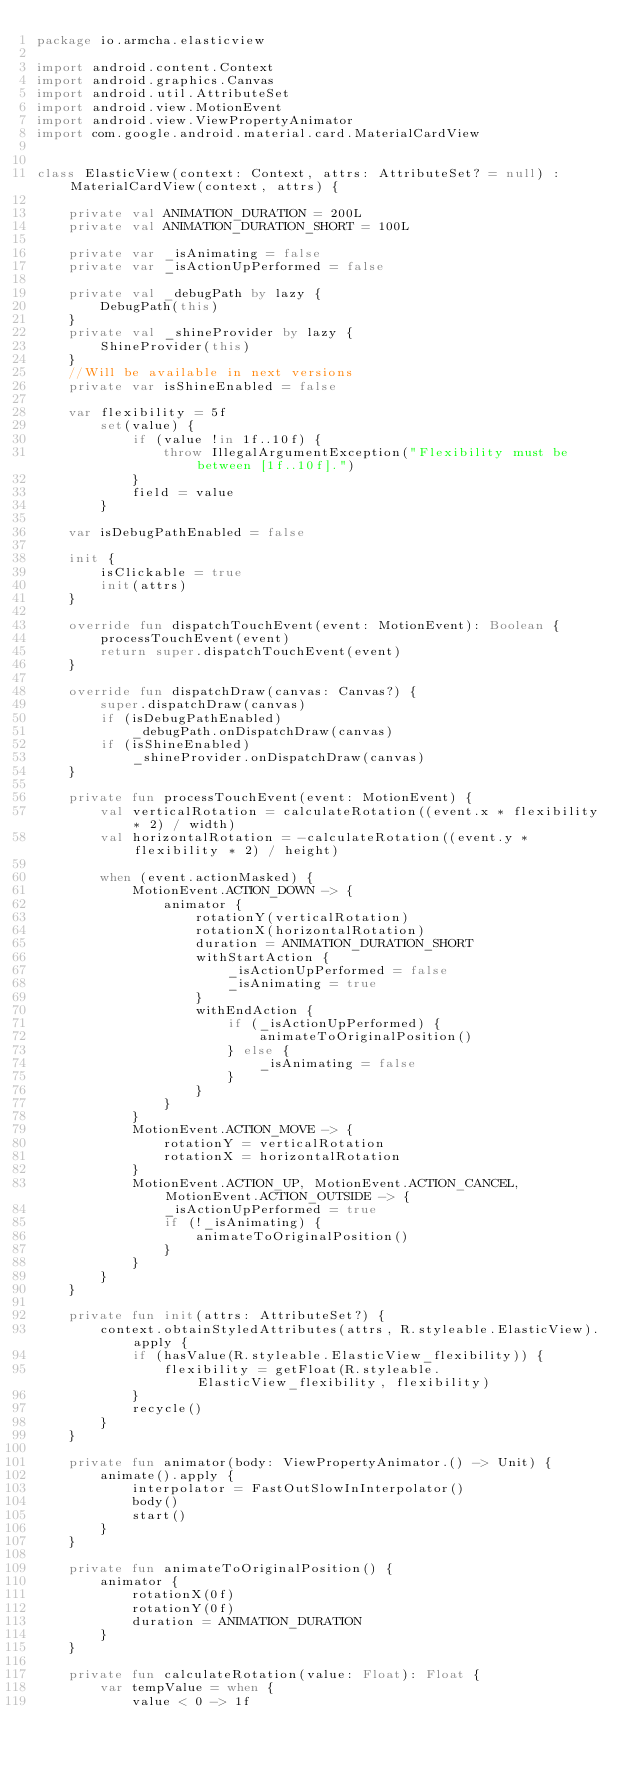Convert code to text. <code><loc_0><loc_0><loc_500><loc_500><_Kotlin_>package io.armcha.elasticview

import android.content.Context
import android.graphics.Canvas
import android.util.AttributeSet
import android.view.MotionEvent
import android.view.ViewPropertyAnimator
import com.google.android.material.card.MaterialCardView


class ElasticView(context: Context, attrs: AttributeSet? = null) : MaterialCardView(context, attrs) {

    private val ANIMATION_DURATION = 200L
    private val ANIMATION_DURATION_SHORT = 100L

    private var _isAnimating = false
    private var _isActionUpPerformed = false

    private val _debugPath by lazy {
        DebugPath(this)
    }
    private val _shineProvider by lazy {
        ShineProvider(this)
    }
    //Will be available in next versions
    private var isShineEnabled = false

    var flexibility = 5f
        set(value) {
            if (value !in 1f..10f) {
                throw IllegalArgumentException("Flexibility must be between [1f..10f].")
            }
            field = value
        }

    var isDebugPathEnabled = false

    init {
        isClickable = true
        init(attrs)
    }

    override fun dispatchTouchEvent(event: MotionEvent): Boolean {
        processTouchEvent(event)
        return super.dispatchTouchEvent(event)
    }

    override fun dispatchDraw(canvas: Canvas?) {
        super.dispatchDraw(canvas)
        if (isDebugPathEnabled)
            _debugPath.onDispatchDraw(canvas)
        if (isShineEnabled)
            _shineProvider.onDispatchDraw(canvas)
    }

    private fun processTouchEvent(event: MotionEvent) {
        val verticalRotation = calculateRotation((event.x * flexibility * 2) / width)
        val horizontalRotation = -calculateRotation((event.y * flexibility * 2) / height)

        when (event.actionMasked) {
            MotionEvent.ACTION_DOWN -> {
                animator {
                    rotationY(verticalRotation)
                    rotationX(horizontalRotation)
                    duration = ANIMATION_DURATION_SHORT
                    withStartAction {
                        _isActionUpPerformed = false
                        _isAnimating = true
                    }
                    withEndAction {
                        if (_isActionUpPerformed) {
                            animateToOriginalPosition()
                        } else {
                            _isAnimating = false
                        }
                    }
                }
            }
            MotionEvent.ACTION_MOVE -> {
                rotationY = verticalRotation
                rotationX = horizontalRotation
            }
            MotionEvent.ACTION_UP, MotionEvent.ACTION_CANCEL, MotionEvent.ACTION_OUTSIDE -> {
                _isActionUpPerformed = true
                if (!_isAnimating) {
                    animateToOriginalPosition()
                }
            }
        }
    }

    private fun init(attrs: AttributeSet?) {
        context.obtainStyledAttributes(attrs, R.styleable.ElasticView).apply {
            if (hasValue(R.styleable.ElasticView_flexibility)) {
                flexibility = getFloat(R.styleable.ElasticView_flexibility, flexibility)
            }
            recycle()
        }
    }

    private fun animator(body: ViewPropertyAnimator.() -> Unit) {
        animate().apply {
            interpolator = FastOutSlowInInterpolator()
            body()
            start()
        }
    }

    private fun animateToOriginalPosition() {
        animator {
            rotationX(0f)
            rotationY(0f)
            duration = ANIMATION_DURATION
        }
    }

    private fun calculateRotation(value: Float): Float {
        var tempValue = when {
            value < 0 -> 1f</code> 